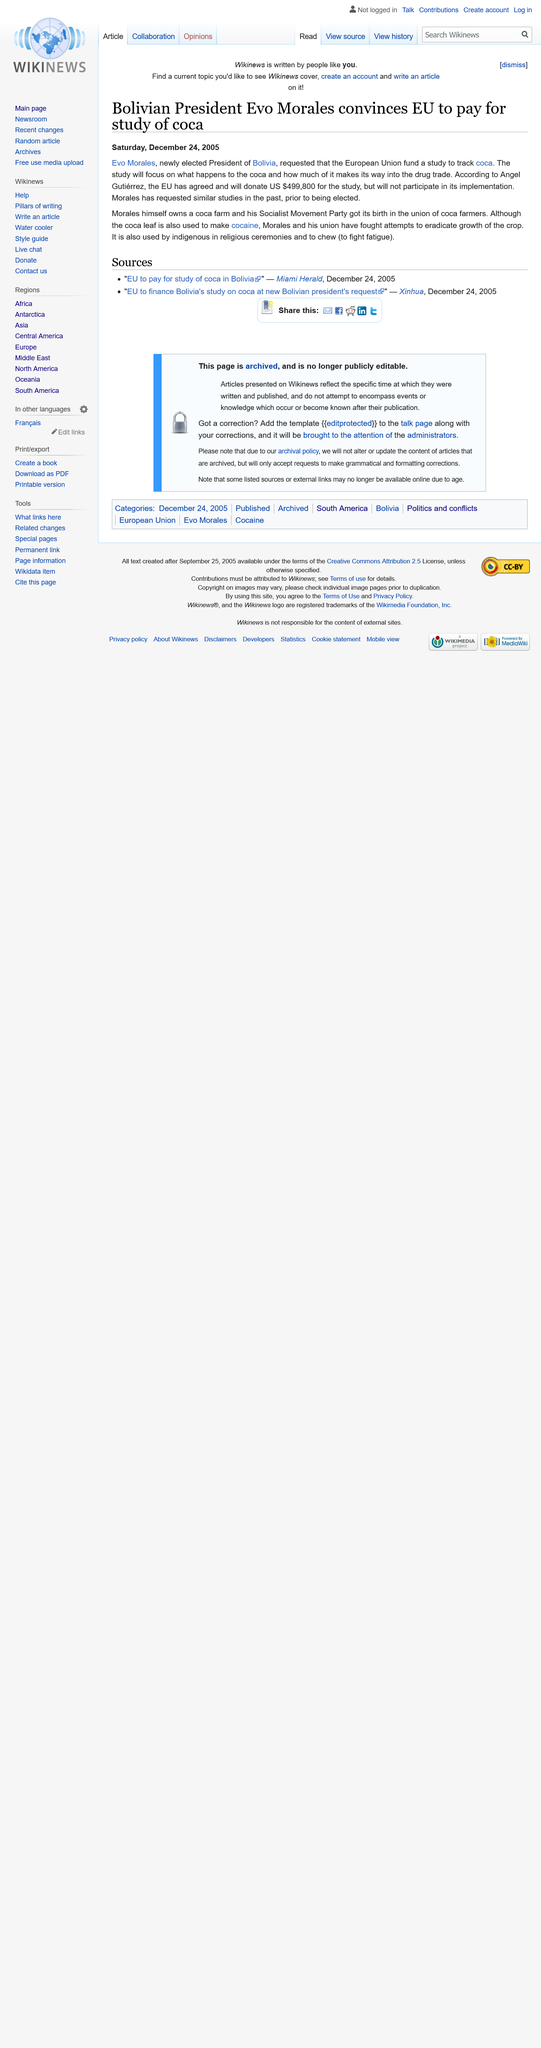Draw attention to some important aspects in this diagram. Evo Morales was the president of Bolivia, a country in South America. Coca leaf is used to make cocaine. The European Union will fund a study to monitor the use of coca. 